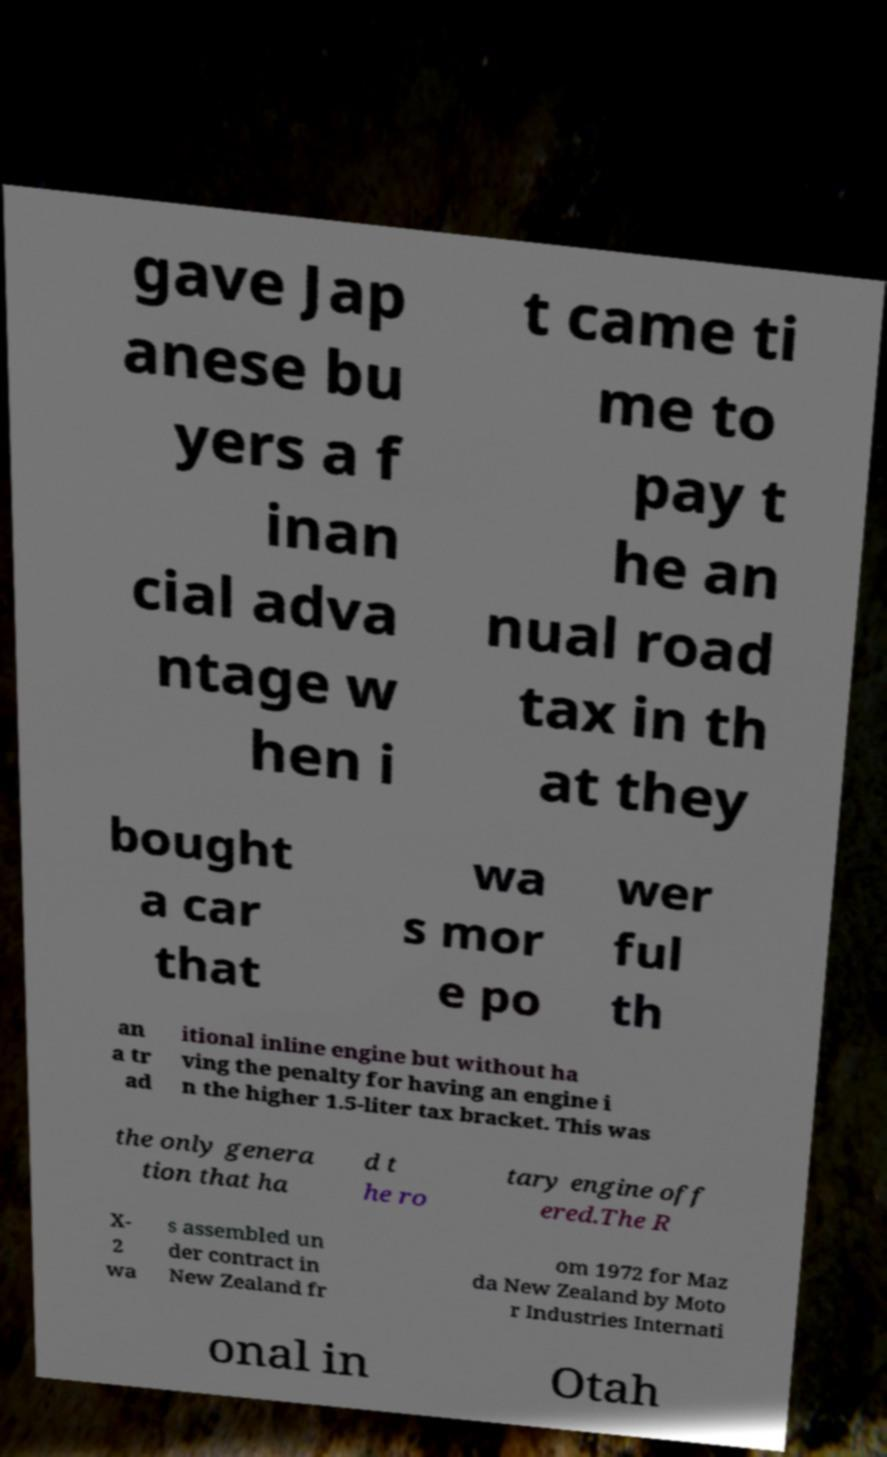Can you accurately transcribe the text from the provided image for me? gave Jap anese bu yers a f inan cial adva ntage w hen i t came ti me to pay t he an nual road tax in th at they bought a car that wa s mor e po wer ful th an a tr ad itional inline engine but without ha ving the penalty for having an engine i n the higher 1.5-liter tax bracket. This was the only genera tion that ha d t he ro tary engine off ered.The R X- 2 wa s assembled un der contract in New Zealand fr om 1972 for Maz da New Zealand by Moto r Industries Internati onal in Otah 